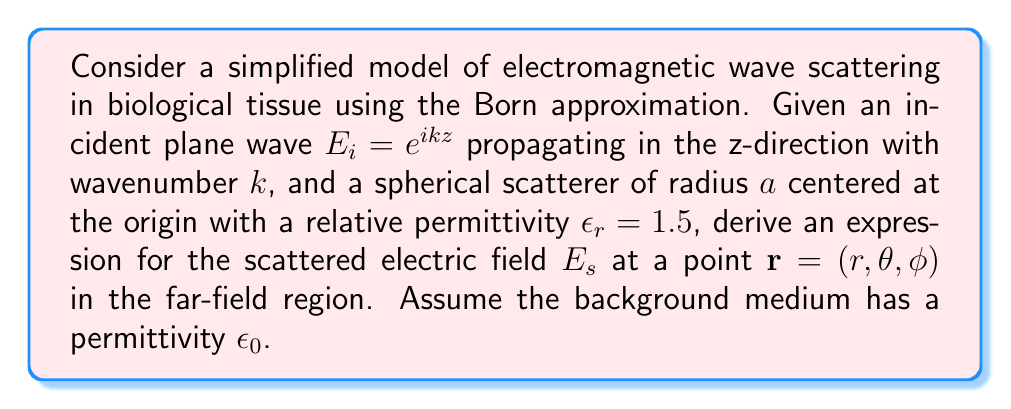Could you help me with this problem? Let's approach this step-by-step:

1) The Born approximation for the scattered field is given by the integral equation:

   $$E_s(\mathbf{r}) = k^2 \int_V (\epsilon_r(\mathbf{r}') - 1) E_i(\mathbf{r}') G(\mathbf{r}, \mathbf{r}') d\mathbf{r}'$$

   where $G(\mathbf{r}, \mathbf{r}')$ is the Green's function.

2) For a homogeneous sphere, $\epsilon_r(\mathbf{r}') - 1 = 0.5$ inside the sphere and 0 outside.

3) The Green's function in the far-field approximation is:

   $$G(\mathbf{r}, \mathbf{r}') \approx \frac{e^{ikr}}{4\pi r} e^{-ik\hat{\mathbf{r}} \cdot \mathbf{r}'}$$

4) Substituting these into the integral:

   $$E_s(\mathbf{r}) = \frac{k^2 e^{ikr}}{4\pi r} 0.5 \int_{V_sphere} e^{ikz'} e^{-ik\hat{\mathbf{r}} \cdot \mathbf{r}'} d\mathbf{r}'$$

5) In spherical coordinates, $\hat{\mathbf{r}} \cdot \mathbf{r}' = r' \cos\theta'$, and $z' = r' \cos\theta'$. The integral becomes:

   $$E_s(\mathbf{r}) = \frac{k^2 e^{ikr}}{8\pi r} \int_0^a \int_0^\pi \int_0^{2\pi} e^{ikr'(\cos\theta' - \cos\theta)} r'^2 \sin\theta' dr' d\theta' d\phi'$$

6) Integrating over $\phi'$ gives a factor of $2\pi$. The $\theta'$ integral can be evaluated to give:

   $$E_s(\mathbf{r}) = \frac{k^2 e^{ikr}}{4r} \int_0^a \frac{\sin(kr'(1-\cos\theta))}{k(1-\cos\theta)} r'^2 dr'$$

7) The remaining integral can be solved to give:

   $$E_s(\mathbf{r}) = \frac{k^2 a^3 e^{ikr}}{3r} \frac{3}{(ka(1-\cos\theta))^3} [\sin(ka(1-\cos\theta)) - ka(1-\cos\theta)\cos(ka(1-\cos\theta))]$$

This is the expression for the scattered electric field in the far-field region.
Answer: $$E_s(\mathbf{r}) = \frac{k^2 a^3 e^{ikr}}{3r} \frac{3}{(ka(1-\cos\theta))^3} [\sin(ka(1-\cos\theta)) - ka(1-\cos\theta)\cos(ka(1-\cos\theta))]$$ 